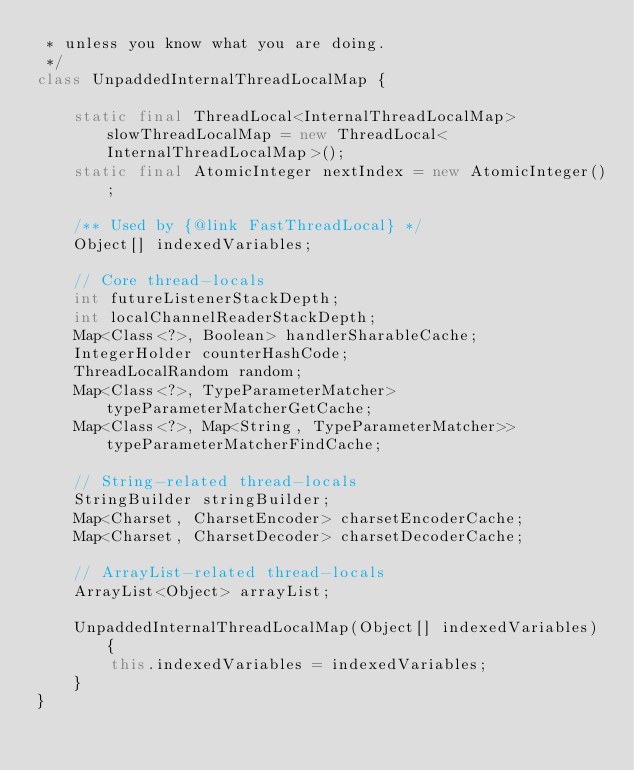Convert code to text. <code><loc_0><loc_0><loc_500><loc_500><_Java_> * unless you know what you are doing.
 */
class UnpaddedInternalThreadLocalMap {

    static final ThreadLocal<InternalThreadLocalMap> slowThreadLocalMap = new ThreadLocal<InternalThreadLocalMap>();
    static final AtomicInteger nextIndex = new AtomicInteger();

    /** Used by {@link FastThreadLocal} */
    Object[] indexedVariables;

    // Core thread-locals
    int futureListenerStackDepth;
    int localChannelReaderStackDepth;
    Map<Class<?>, Boolean> handlerSharableCache;
    IntegerHolder counterHashCode;
    ThreadLocalRandom random;
    Map<Class<?>, TypeParameterMatcher> typeParameterMatcherGetCache;
    Map<Class<?>, Map<String, TypeParameterMatcher>> typeParameterMatcherFindCache;

    // String-related thread-locals
    StringBuilder stringBuilder;
    Map<Charset, CharsetEncoder> charsetEncoderCache;
    Map<Charset, CharsetDecoder> charsetDecoderCache;

    // ArrayList-related thread-locals
    ArrayList<Object> arrayList;

    UnpaddedInternalThreadLocalMap(Object[] indexedVariables) {
        this.indexedVariables = indexedVariables;
    }
}
</code> 